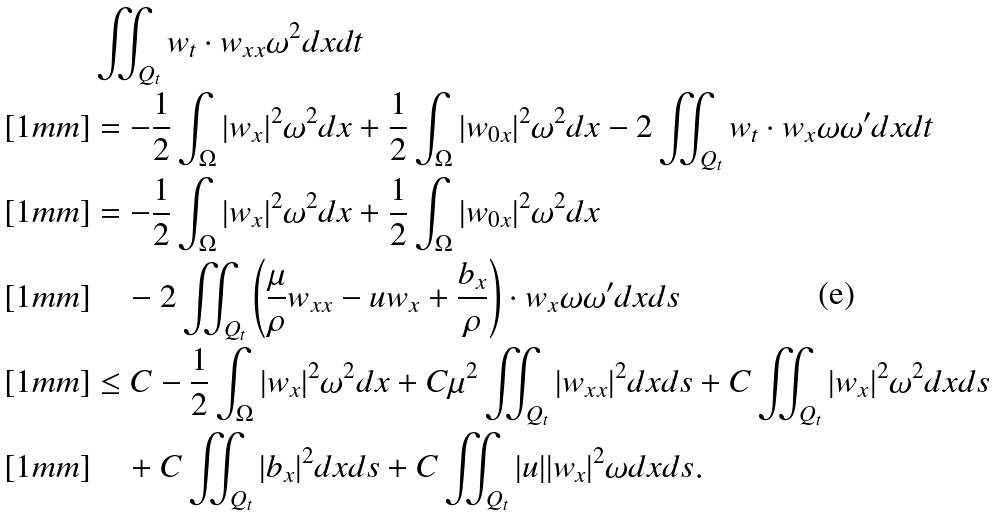Convert formula to latex. <formula><loc_0><loc_0><loc_500><loc_500>& \iint _ { Q _ { t } } w _ { t } \cdot w _ { x x } \omega ^ { 2 } d x d t \\ [ 1 m m ] & = - \frac { 1 } { 2 } \int _ { \Omega } | w _ { x } | ^ { 2 } \omega ^ { 2 } d x + \frac { 1 } { 2 } \int _ { \Omega } | w _ { 0 x } | ^ { 2 } \omega ^ { 2 } d x - 2 \iint _ { Q _ { t } } w _ { t } \cdot w _ { x } \omega \omega ^ { \prime } d x d t \\ [ 1 m m ] & = - \frac { 1 } { 2 } \int _ { \Omega } | w _ { x } | ^ { 2 } \omega ^ { 2 } d x + \frac { 1 } { 2 } \int _ { \Omega } | w _ { 0 x } | ^ { 2 } \omega ^ { 2 } d x \\ [ 1 m m ] & \quad - 2 \iint _ { Q _ { t } } \left ( \frac { \mu } { \rho } w _ { x x } - u w _ { x } + \frac { b _ { x } } { \rho } \right ) \cdot w _ { x } \omega \omega ^ { \prime } d x d s \\ [ 1 m m ] & \leq C - \frac { 1 } { 2 } \int _ { \Omega } | w _ { x } | ^ { 2 } \omega ^ { 2 } d x + C \mu ^ { 2 } \iint _ { Q _ { t } } | w _ { x x } | ^ { 2 } d x d s + C \iint _ { Q _ { t } } | w _ { x } | ^ { 2 } \omega ^ { 2 } d x d s \\ [ 1 m m ] & \quad + C \iint _ { Q _ { t } } | b _ { x } | ^ { 2 } d x d s + C \iint _ { Q _ { t } } | u | | w _ { x } | ^ { 2 } \omega d x d s .</formula> 